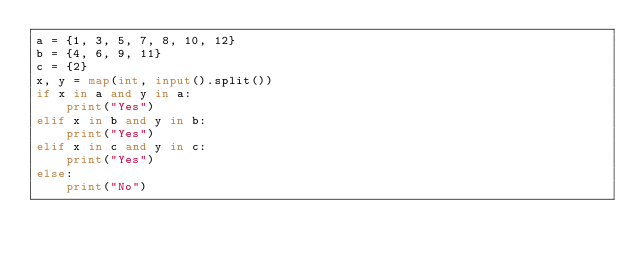<code> <loc_0><loc_0><loc_500><loc_500><_Python_>a = {1, 3, 5, 7, 8, 10, 12}
b = {4, 6, 9, 11}
c = {2}
x, y = map(int, input().split())
if x in a and y in a:
    print("Yes")
elif x in b and y in b:
    print("Yes")
elif x in c and y in c:
    print("Yes")
else:
    print("No")</code> 